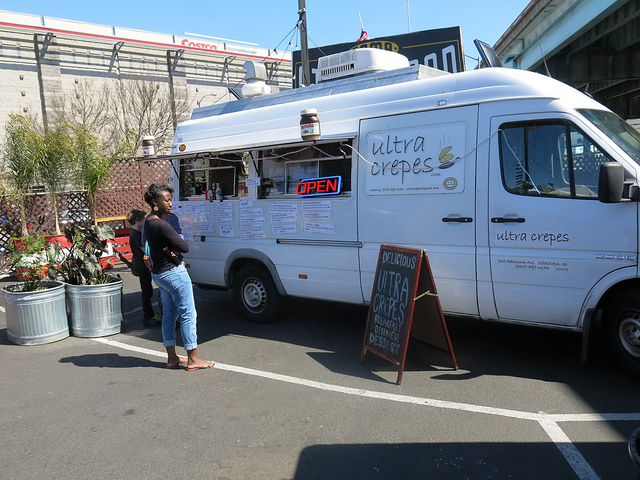Is the food truck currently open for business? Yes, the truck appears to be open for business, as indicated by the 'OPEN' sign displayed on its window. 